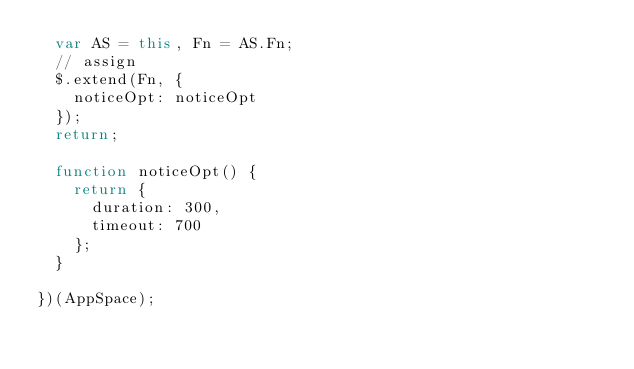Convert code to text. <code><loc_0><loc_0><loc_500><loc_500><_JavaScript_>  var AS = this, Fn = AS.Fn;
  // assign
  $.extend(Fn, {
    noticeOpt: noticeOpt
  });
  return;

  function noticeOpt() {
    return {
      duration: 300,
      timeout: 700
    };
  }

})(AppSpace);
</code> 